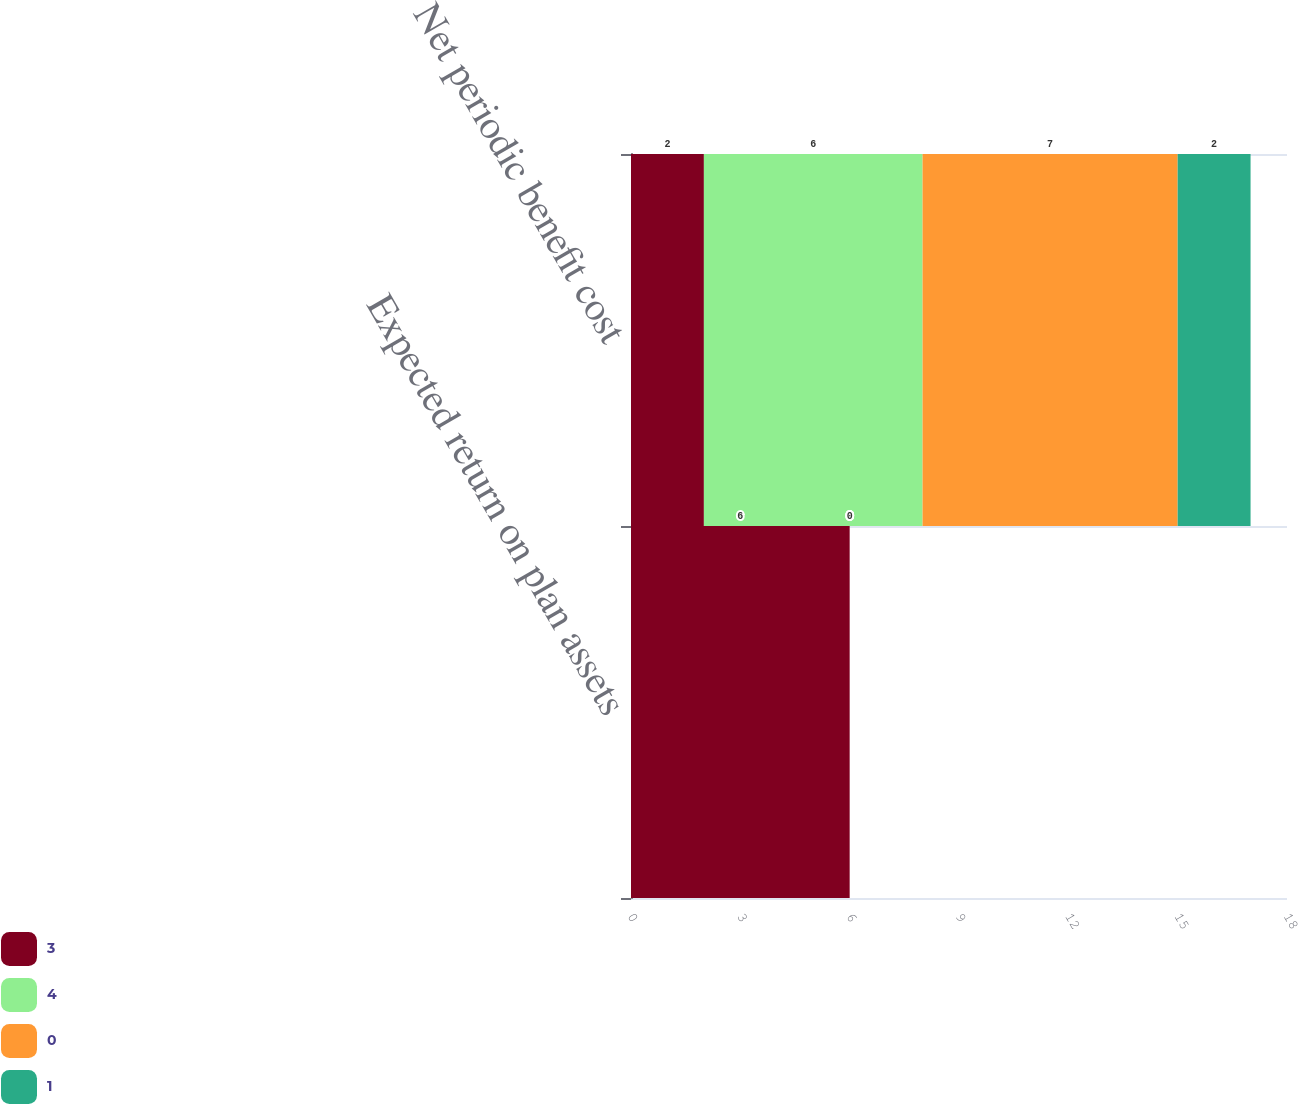Convert chart. <chart><loc_0><loc_0><loc_500><loc_500><stacked_bar_chart><ecel><fcel>Expected return on plan assets<fcel>Net periodic benefit cost<nl><fcel>3<fcel>6<fcel>2<nl><fcel>4<fcel>0<fcel>6<nl><fcel>0<fcel>0<fcel>7<nl><fcel>1<fcel>0<fcel>2<nl></chart> 